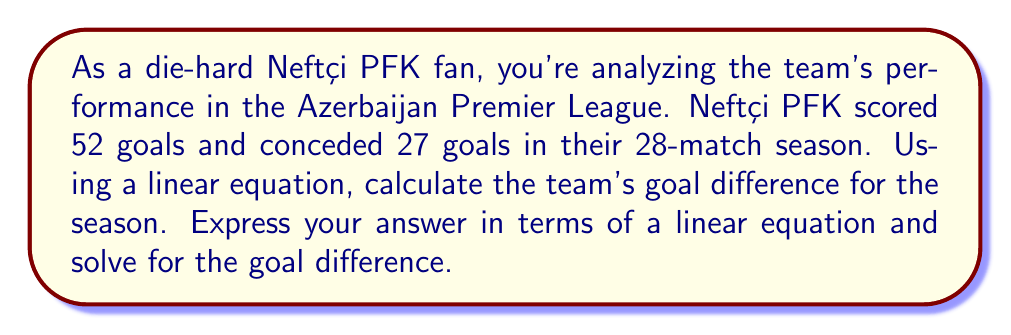Provide a solution to this math problem. Let's approach this step-by-step:

1) First, let's define our variables:
   $x$ = goals scored
   $y$ = goals conceded
   $z$ = goal difference

2) We know that goal difference is calculated by subtracting goals conceded from goals scored. This gives us our linear equation:

   $z = x - y$

3) We're given the following information:
   $x = 52$ (goals scored)
   $y = 27$ (goals conceded)

4) Now, let's substitute these values into our equation:

   $z = 52 - 27$

5) Solve the equation:

   $z = 25$

Therefore, the linear equation representing Neftçi PFK's goal difference is:

$z = 52 - 27$

And solving this equation gives us the goal difference for the season.
Answer: Neftçi PFK's goal difference for the season can be represented by the linear equation:

$z = 52 - 27$

Solving this equation gives a goal difference of 25 for the season. 